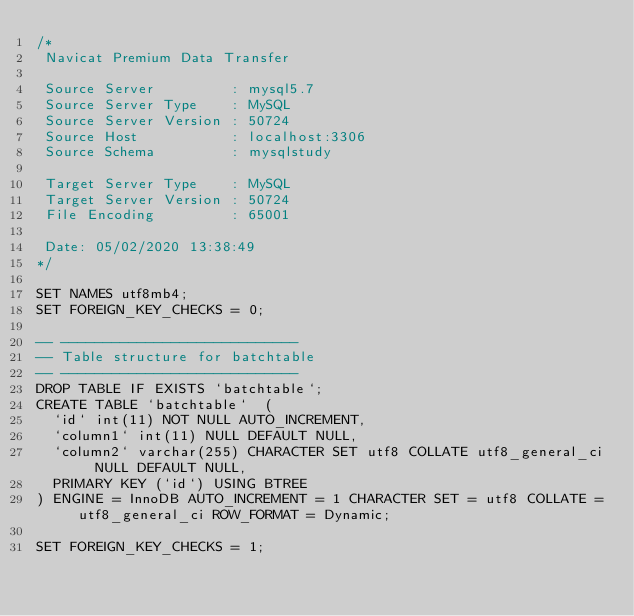<code> <loc_0><loc_0><loc_500><loc_500><_SQL_>/*
 Navicat Premium Data Transfer

 Source Server         : mysql5.7
 Source Server Type    : MySQL
 Source Server Version : 50724
 Source Host           : localhost:3306
 Source Schema         : mysqlstudy

 Target Server Type    : MySQL
 Target Server Version : 50724
 File Encoding         : 65001

 Date: 05/02/2020 13:38:49
*/

SET NAMES utf8mb4;
SET FOREIGN_KEY_CHECKS = 0;

-- ----------------------------
-- Table structure for batchtable
-- ----------------------------
DROP TABLE IF EXISTS `batchtable`;
CREATE TABLE `batchtable`  (
  `id` int(11) NOT NULL AUTO_INCREMENT,
  `column1` int(11) NULL DEFAULT NULL,
  `column2` varchar(255) CHARACTER SET utf8 COLLATE utf8_general_ci NULL DEFAULT NULL,
  PRIMARY KEY (`id`) USING BTREE
) ENGINE = InnoDB AUTO_INCREMENT = 1 CHARACTER SET = utf8 COLLATE = utf8_general_ci ROW_FORMAT = Dynamic;

SET FOREIGN_KEY_CHECKS = 1;
</code> 